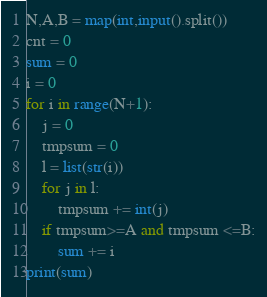<code> <loc_0><loc_0><loc_500><loc_500><_Python_>N,A,B = map(int,input().split())
cnt = 0
sum = 0
i = 0
for i in range(N+1):
    j = 0
    tmpsum = 0
    l = list(str(i))
    for j in l:
        tmpsum += int(j)
    if tmpsum>=A and tmpsum <=B:
        sum += i
print(sum)</code> 